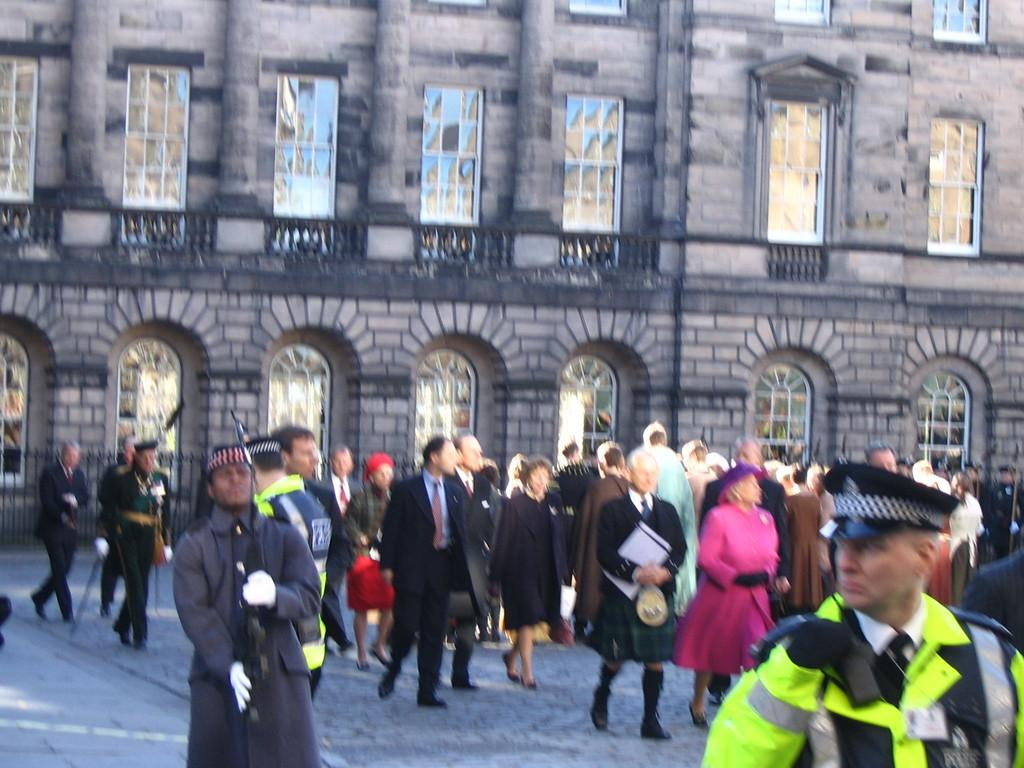What is the main feature of the image? There is a road in the image. What are the people in the image doing? There are people walking in the image. What can be seen in the background of the image? There is a building with stones visible in the background. What material are the windows of the building made of? The windows of the building have glasses. How many cars are parked under the shade in the image? There are no cars or shade present in the image. What type of show is being performed on the road in the image? There is no show being performed on the road in the image. 